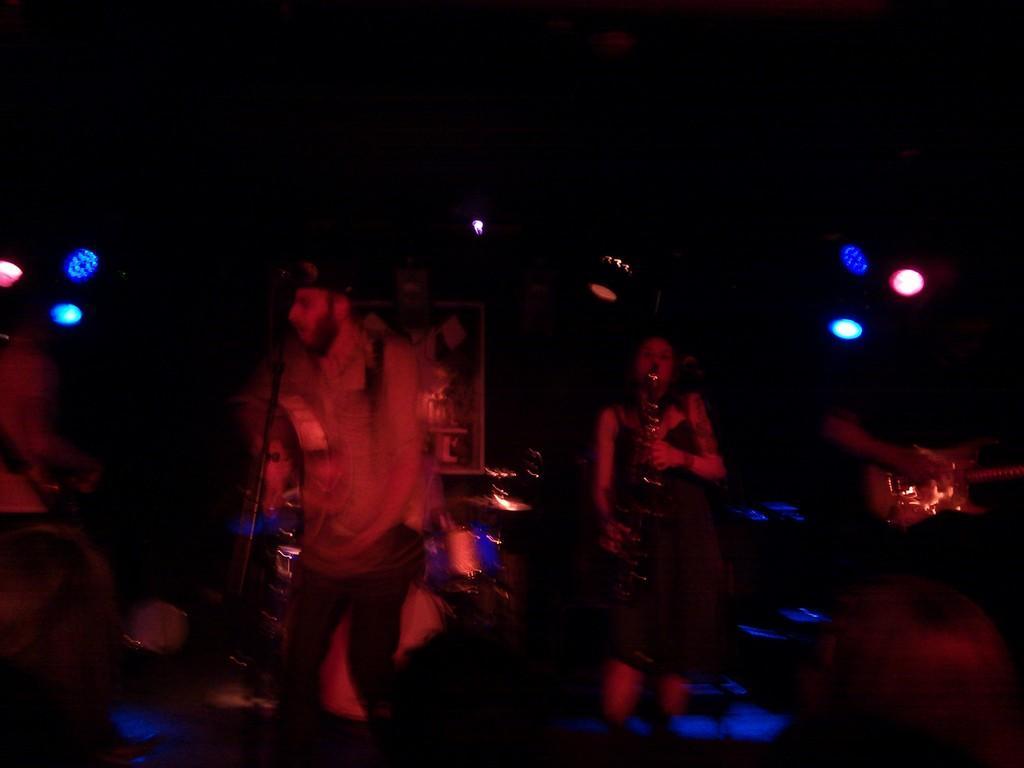Please provide a concise description of this image. In this image we can see a few people holding musical instruments, behind them there are some objects on the surface and in the background we can see the lights. 